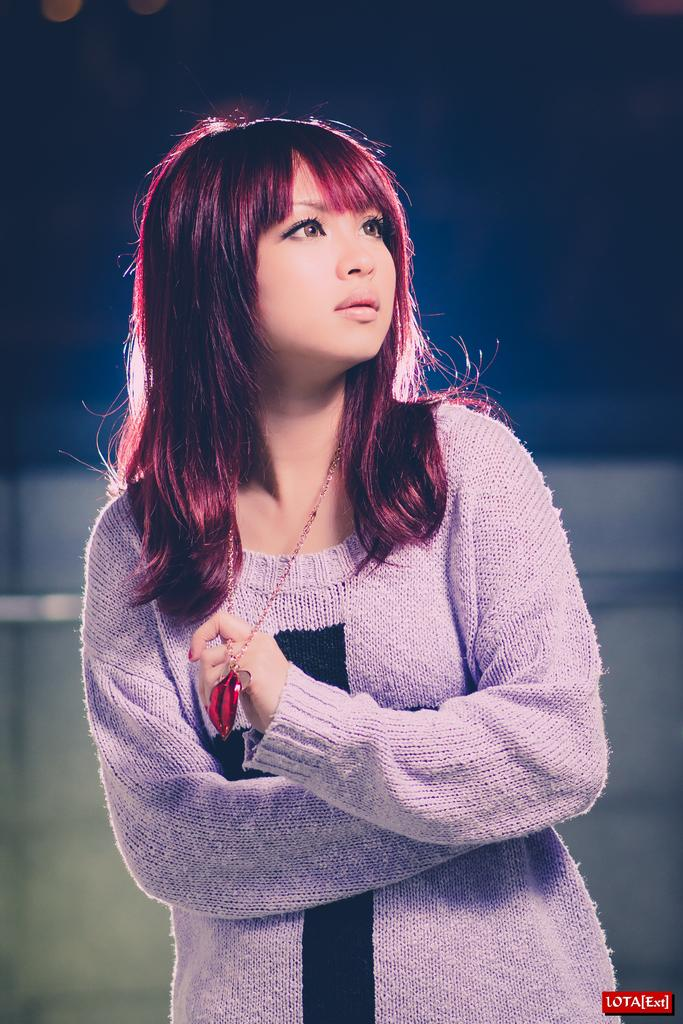Who is the main subject in the image? There is a woman in the image. What is the woman wearing? The woman is wearing a purple dress and a chain. Can you describe the background of the image? The background of the image is blurred. What type of whip is the woman using in the image? There is no whip present in the image. What rhythm is the woman following in the image? The image does not depict any rhythm or musical activity. 